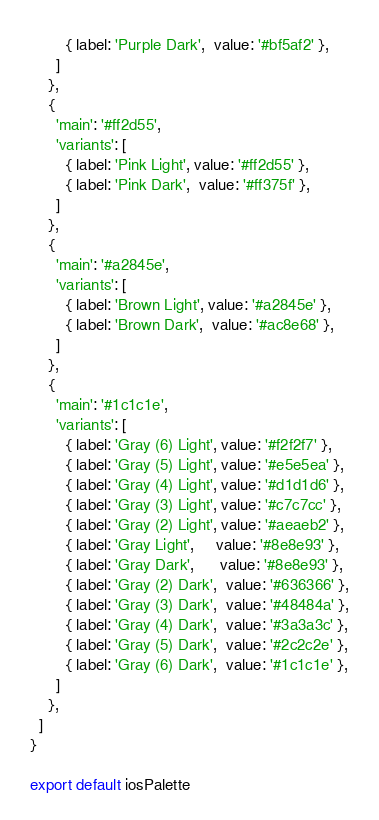Convert code to text. <code><loc_0><loc_0><loc_500><loc_500><_JavaScript_>        { label: 'Purple Dark',  value: '#bf5af2' },
      ]
    },
    {
      'main': '#ff2d55',
      'variants': [
        { label: 'Pink Light', value: '#ff2d55' },
        { label: 'Pink Dark',  value: '#ff375f' },
      ]
    },
    {
      'main': '#a2845e',
      'variants': [
        { label: 'Brown Light', value: '#a2845e' },
        { label: 'Brown Dark',  value: '#ac8e68' },
      ]
    },
    {
      'main': '#1c1c1e',
      'variants': [
        { label: 'Gray (6) Light', value: '#f2f2f7' },
        { label: 'Gray (5) Light', value: '#e5e5ea' },
        { label: 'Gray (4) Light', value: '#d1d1d6' },
        { label: 'Gray (3) Light', value: '#c7c7cc' },
        { label: 'Gray (2) Light', value: '#aeaeb2' },
        { label: 'Gray Light',     value: '#8e8e93' },
        { label: 'Gray Dark',      value: '#8e8e93' },
        { label: 'Gray (2) Dark',  value: '#636366' },
        { label: 'Gray (3) Dark',  value: '#48484a' },
        { label: 'Gray (4) Dark',  value: '#3a3a3c' },
        { label: 'Gray (5) Dark',  value: '#2c2c2e' },
        { label: 'Gray (6) Dark',  value: '#1c1c1e' },
      ]
    },
  ]
}

export default iosPalette
</code> 